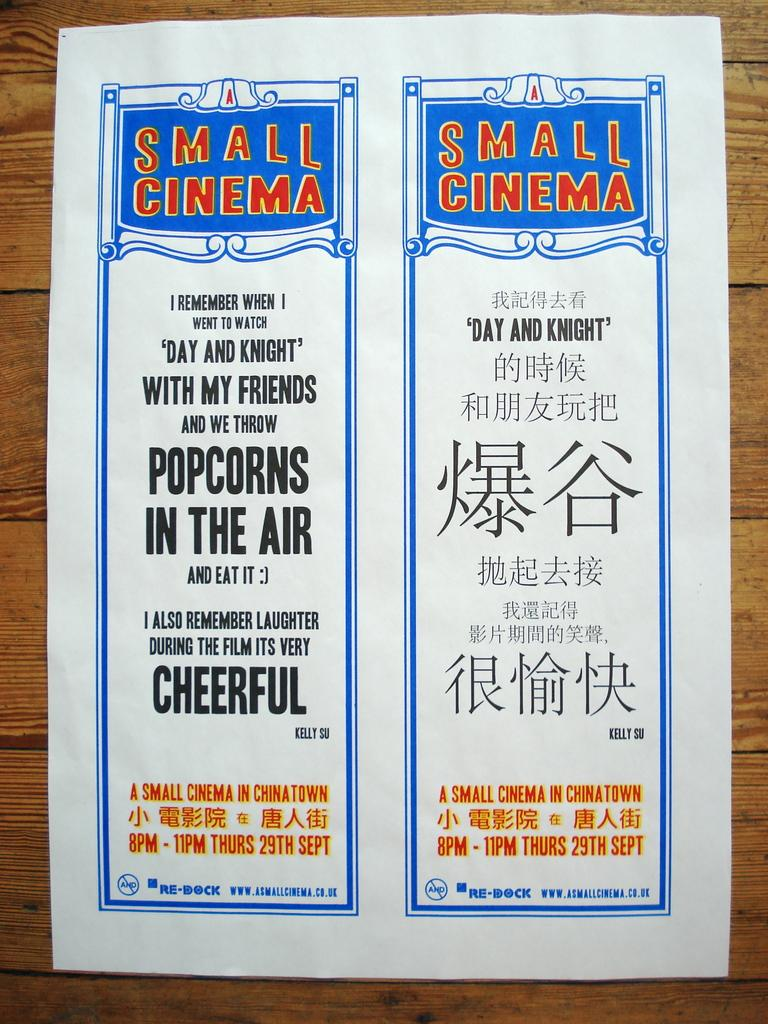Provide a one-sentence caption for the provided image. a sign ad written in english and chinese. 